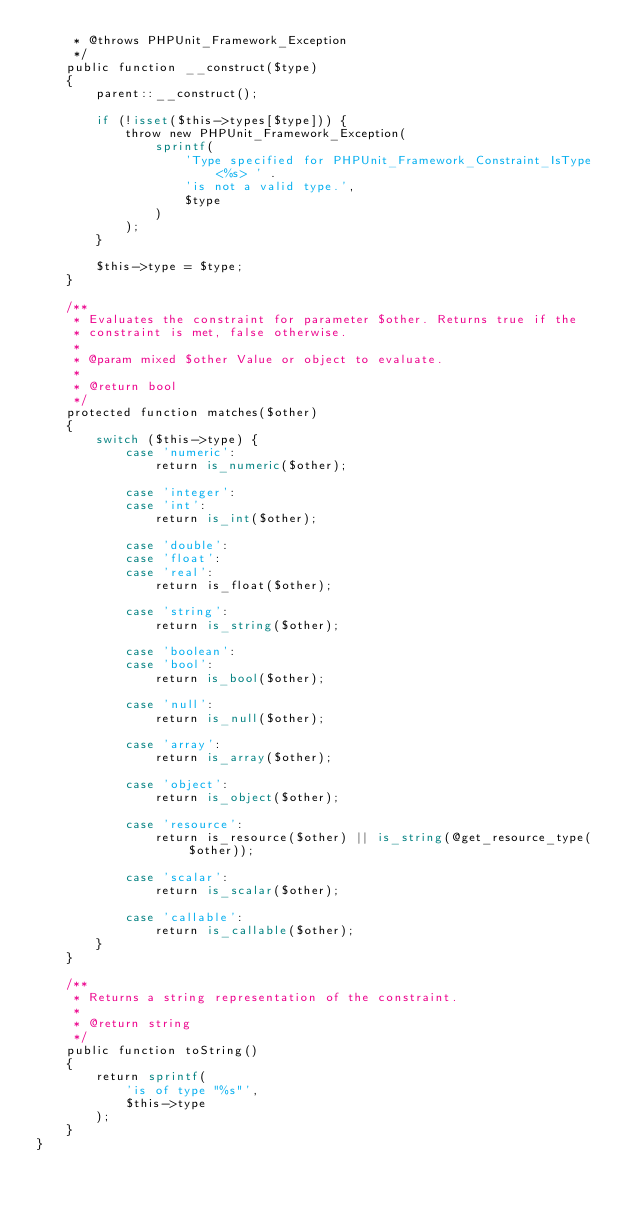Convert code to text. <code><loc_0><loc_0><loc_500><loc_500><_PHP_>     * @throws PHPUnit_Framework_Exception
     */
    public function __construct($type)
    {
        parent::__construct();

        if (!isset($this->types[$type])) {
            throw new PHPUnit_Framework_Exception(
                sprintf(
                    'Type specified for PHPUnit_Framework_Constraint_IsType <%s> ' .
                    'is not a valid type.',
                    $type
                )
            );
        }

        $this->type = $type;
    }

    /**
     * Evaluates the constraint for parameter $other. Returns true if the
     * constraint is met, false otherwise.
     *
     * @param mixed $other Value or object to evaluate.
     *
     * @return bool
     */
    protected function matches($other)
    {
        switch ($this->type) {
            case 'numeric':
                return is_numeric($other);

            case 'integer':
            case 'int':
                return is_int($other);

            case 'double':
            case 'float':
            case 'real':
                return is_float($other);

            case 'string':
                return is_string($other);

            case 'boolean':
            case 'bool':
                return is_bool($other);

            case 'null':
                return is_null($other);

            case 'array':
                return is_array($other);

            case 'object':
                return is_object($other);

            case 'resource':
                return is_resource($other) || is_string(@get_resource_type($other));

            case 'scalar':
                return is_scalar($other);

            case 'callable':
                return is_callable($other);
        }
    }

    /**
     * Returns a string representation of the constraint.
     *
     * @return string
     */
    public function toString()
    {
        return sprintf(
            'is of type "%s"',
            $this->type
        );
    }
}
</code> 